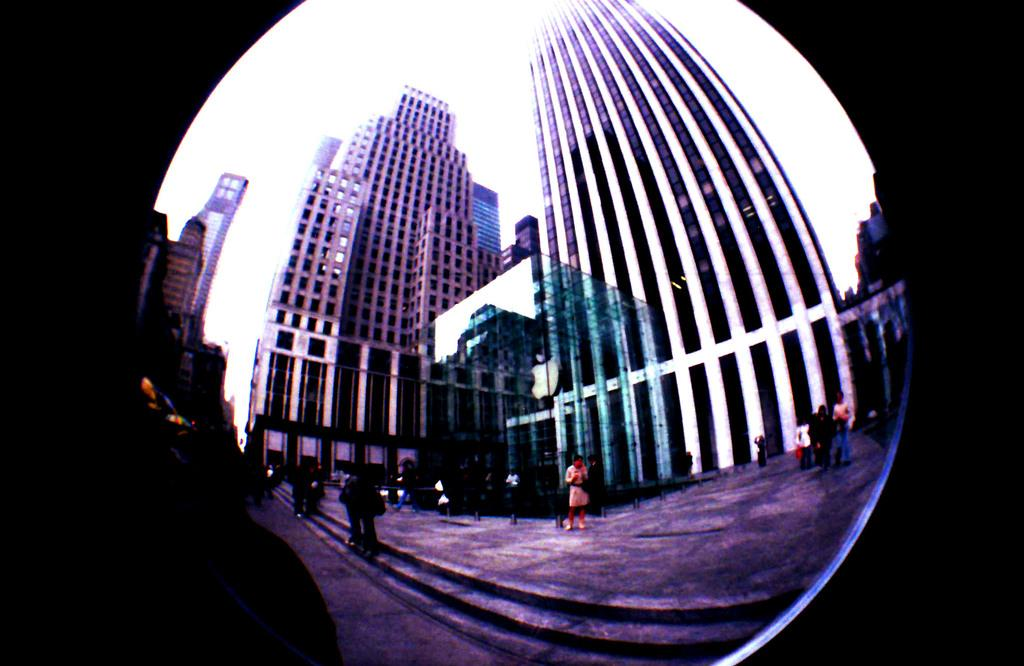What structures are visible in the image? There are buildings in the image. What is happening in front of the buildings? There are people standing in front of the buildings. What type of net is being used to produce a show in the image? There is no net or show production present in the image; it features buildings and people standing in front of them. 